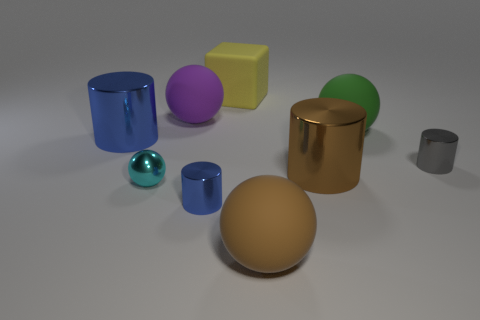Add 1 small cyan rubber cubes. How many objects exist? 10 Subtract all large blue metallic cylinders. How many cylinders are left? 3 Subtract all brown cylinders. How many cylinders are left? 3 Subtract 2 cylinders. How many cylinders are left? 2 Add 6 small metal cylinders. How many small metal cylinders exist? 8 Subtract 1 blue cylinders. How many objects are left? 8 Subtract all spheres. How many objects are left? 5 Subtract all red balls. Subtract all purple cubes. How many balls are left? 4 Subtract all gray balls. How many gray blocks are left? 0 Subtract all tiny gray cylinders. Subtract all small gray metal cylinders. How many objects are left? 7 